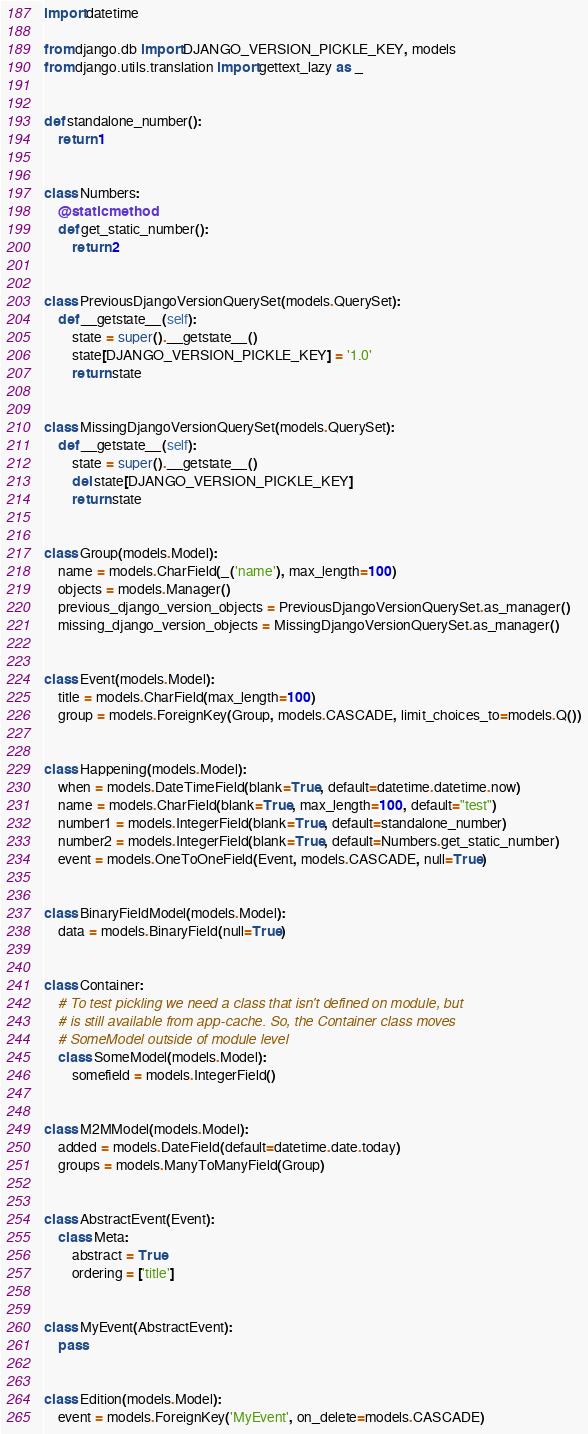Convert code to text. <code><loc_0><loc_0><loc_500><loc_500><_Python_>import datetime

from django.db import DJANGO_VERSION_PICKLE_KEY, models
from django.utils.translation import gettext_lazy as _


def standalone_number():
    return 1


class Numbers:
    @staticmethod
    def get_static_number():
        return 2


class PreviousDjangoVersionQuerySet(models.QuerySet):
    def __getstate__(self):
        state = super().__getstate__()
        state[DJANGO_VERSION_PICKLE_KEY] = '1.0'
        return state


class MissingDjangoVersionQuerySet(models.QuerySet):
    def __getstate__(self):
        state = super().__getstate__()
        del state[DJANGO_VERSION_PICKLE_KEY]
        return state


class Group(models.Model):
    name = models.CharField(_('name'), max_length=100)
    objects = models.Manager()
    previous_django_version_objects = PreviousDjangoVersionQuerySet.as_manager()
    missing_django_version_objects = MissingDjangoVersionQuerySet.as_manager()


class Event(models.Model):
    title = models.CharField(max_length=100)
    group = models.ForeignKey(Group, models.CASCADE, limit_choices_to=models.Q())


class Happening(models.Model):
    when = models.DateTimeField(blank=True, default=datetime.datetime.now)
    name = models.CharField(blank=True, max_length=100, default="test")
    number1 = models.IntegerField(blank=True, default=standalone_number)
    number2 = models.IntegerField(blank=True, default=Numbers.get_static_number)
    event = models.OneToOneField(Event, models.CASCADE, null=True)


class BinaryFieldModel(models.Model):
    data = models.BinaryField(null=True)


class Container:
    # To test pickling we need a class that isn't defined on module, but
    # is still available from app-cache. So, the Container class moves
    # SomeModel outside of module level
    class SomeModel(models.Model):
        somefield = models.IntegerField()


class M2MModel(models.Model):
    added = models.DateField(default=datetime.date.today)
    groups = models.ManyToManyField(Group)


class AbstractEvent(Event):
    class Meta:
        abstract = True
        ordering = ['title']


class MyEvent(AbstractEvent):
    pass


class Edition(models.Model):
    event = models.ForeignKey('MyEvent', on_delete=models.CASCADE)
</code> 